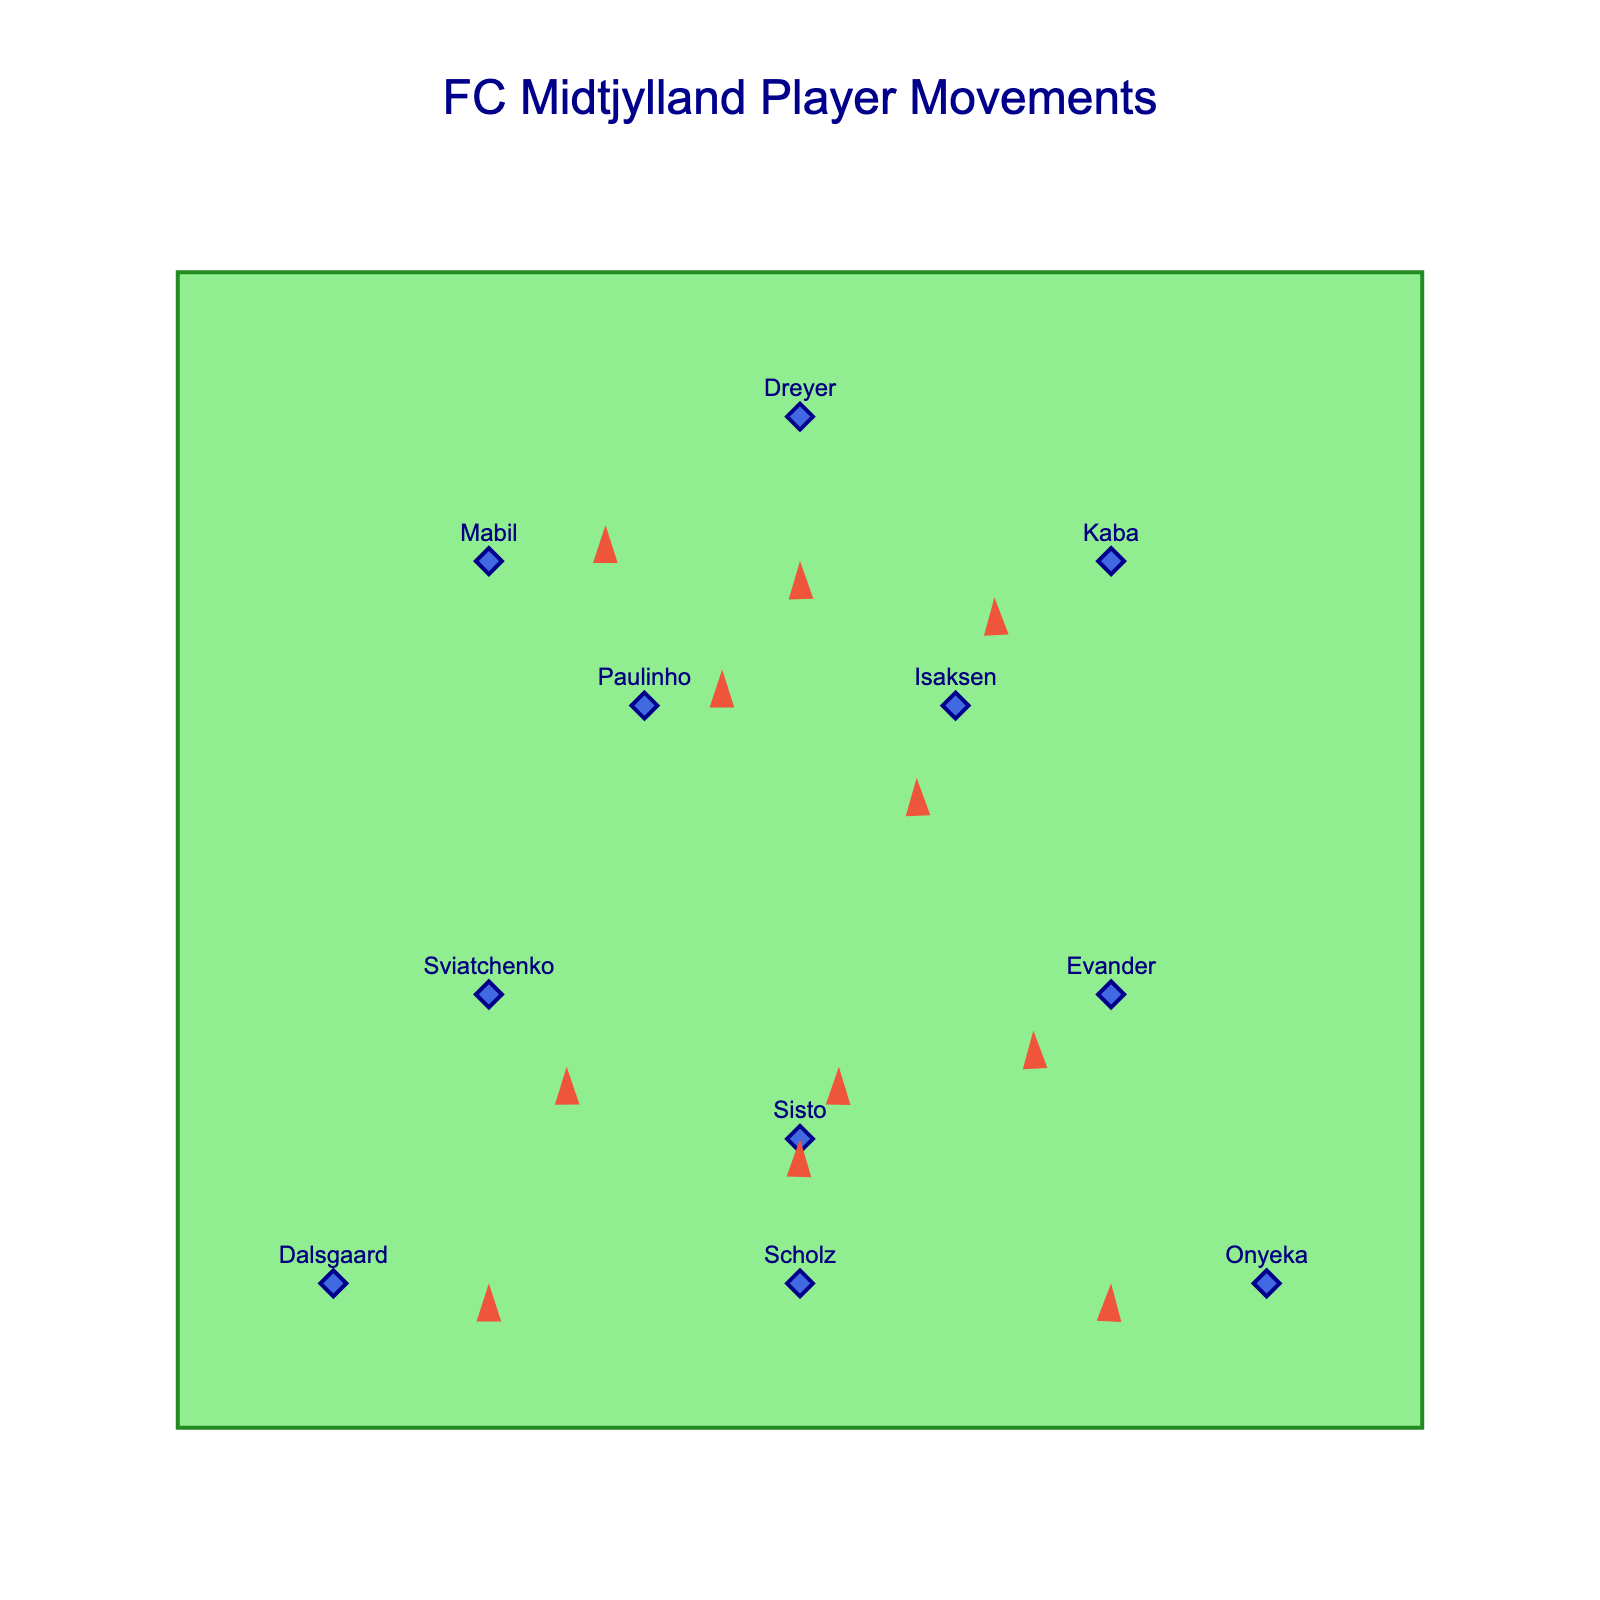What is the title of the plot? The title is displayed at the top of the figure, which reads "FC Midtjylland Player Movements".
Answer: FC Midtjylland Player Movements How many players have movements that include a vertical (y-axis) component? Look at the movement vectors (u, v). Any player with a non-zero 'v' has a vertical component. Players: Sviatchenko, Sisto, Evander, Paulinho, Isaksen, Dreyer, Mabil, and Scholz. Count them.
Answer: 8 Which player has the largest horizontal (x-axis) movement? Compare the absolute values of the 'u' vector for each player. Dalsgaard and Onyeka both have horizontal movements of 2.
Answer: It's a tie between Dalsgaard and Onyeka Who is the player positioned at coordinates (6, 3)? Identify the player from the 'x' and 'y' columns corresponding to these coordinates. The player at (6, 3) is Evander.
Answer: Evander What is the average vertical (y-axis) movement of the players? Sum all 'v' values and then divide by the number of players. The 'v' values are: -1, 1, -0.5, 0.5, -1, 0, 0, -2, 0.5, -0.5, 2. Sum = -1 + 1 -0.5 + 0.5 -1 + 0 + 0 -2 + 0.5 - 0.5 + 2 = -1. Divide by 11 (number of players). -1/11.
Answer: -0.091 Which player has the smallest movement vector? Calculate the magnitude of the movement vector for each player and find the smallest. Magnitude = sqrt(u^2 + v^2). Dreyer has the vector (0, -2), magnitude is sqrt(0^2 + (-2)^2) = 2. Other magnitudes are larger.
Answer: Dreyer Who has the most downward movement? Look for the player with the most negative value in the 'v' column. Dreyer has a 'v' of -2.
Answer: Dreyer What is the total movement distance in the x-direction by Scholz and Mabil combined? Scholz's x-movement is 0. Mabil's x-movement is 1.5. Sum these values: 0 + 1.5 = 1.5.
Answer: 1.5 How does Kaba's movement direction compare to Evander's? Compare the vectors (u, v). Kaba's is (-1.5, -0.5) and Evander's is (-1, -0.5). Both move left and slightly downward.
Answer: Both move left and downward Which player is closest to the middle of the pitch? The middle is at (4, 4). Measure the distance from each player’s position to (4, 4) using the Euclidean distance formula. Dalsgaard is closest.
Answer: Dalsgaard 